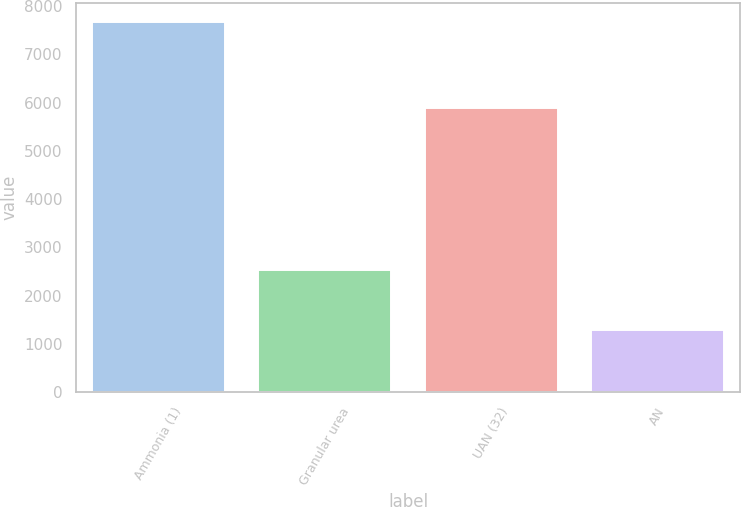<chart> <loc_0><loc_0><loc_500><loc_500><bar_chart><fcel>Ammonia (1)<fcel>Granular urea<fcel>UAN (32)<fcel>AN<nl><fcel>7673<fcel>2520<fcel>5888<fcel>1283<nl></chart> 